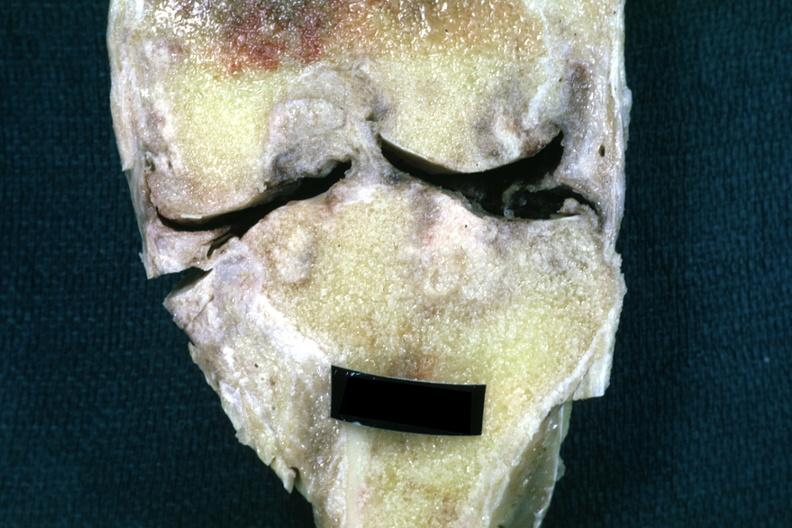what is present?
Answer the question using a single word or phrase. Joints 